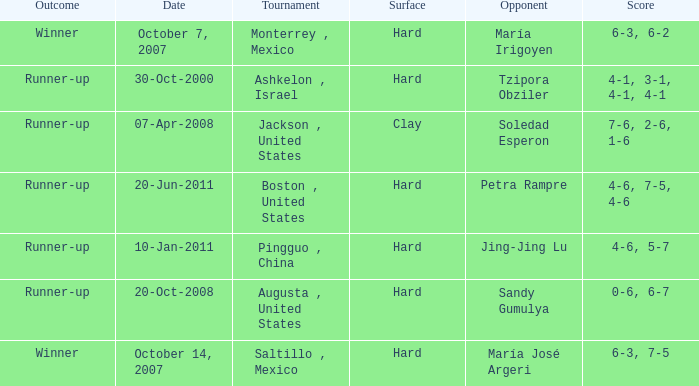Who was the opponent with a score of 4-6, 7-5, 4-6? Petra Rampre. 